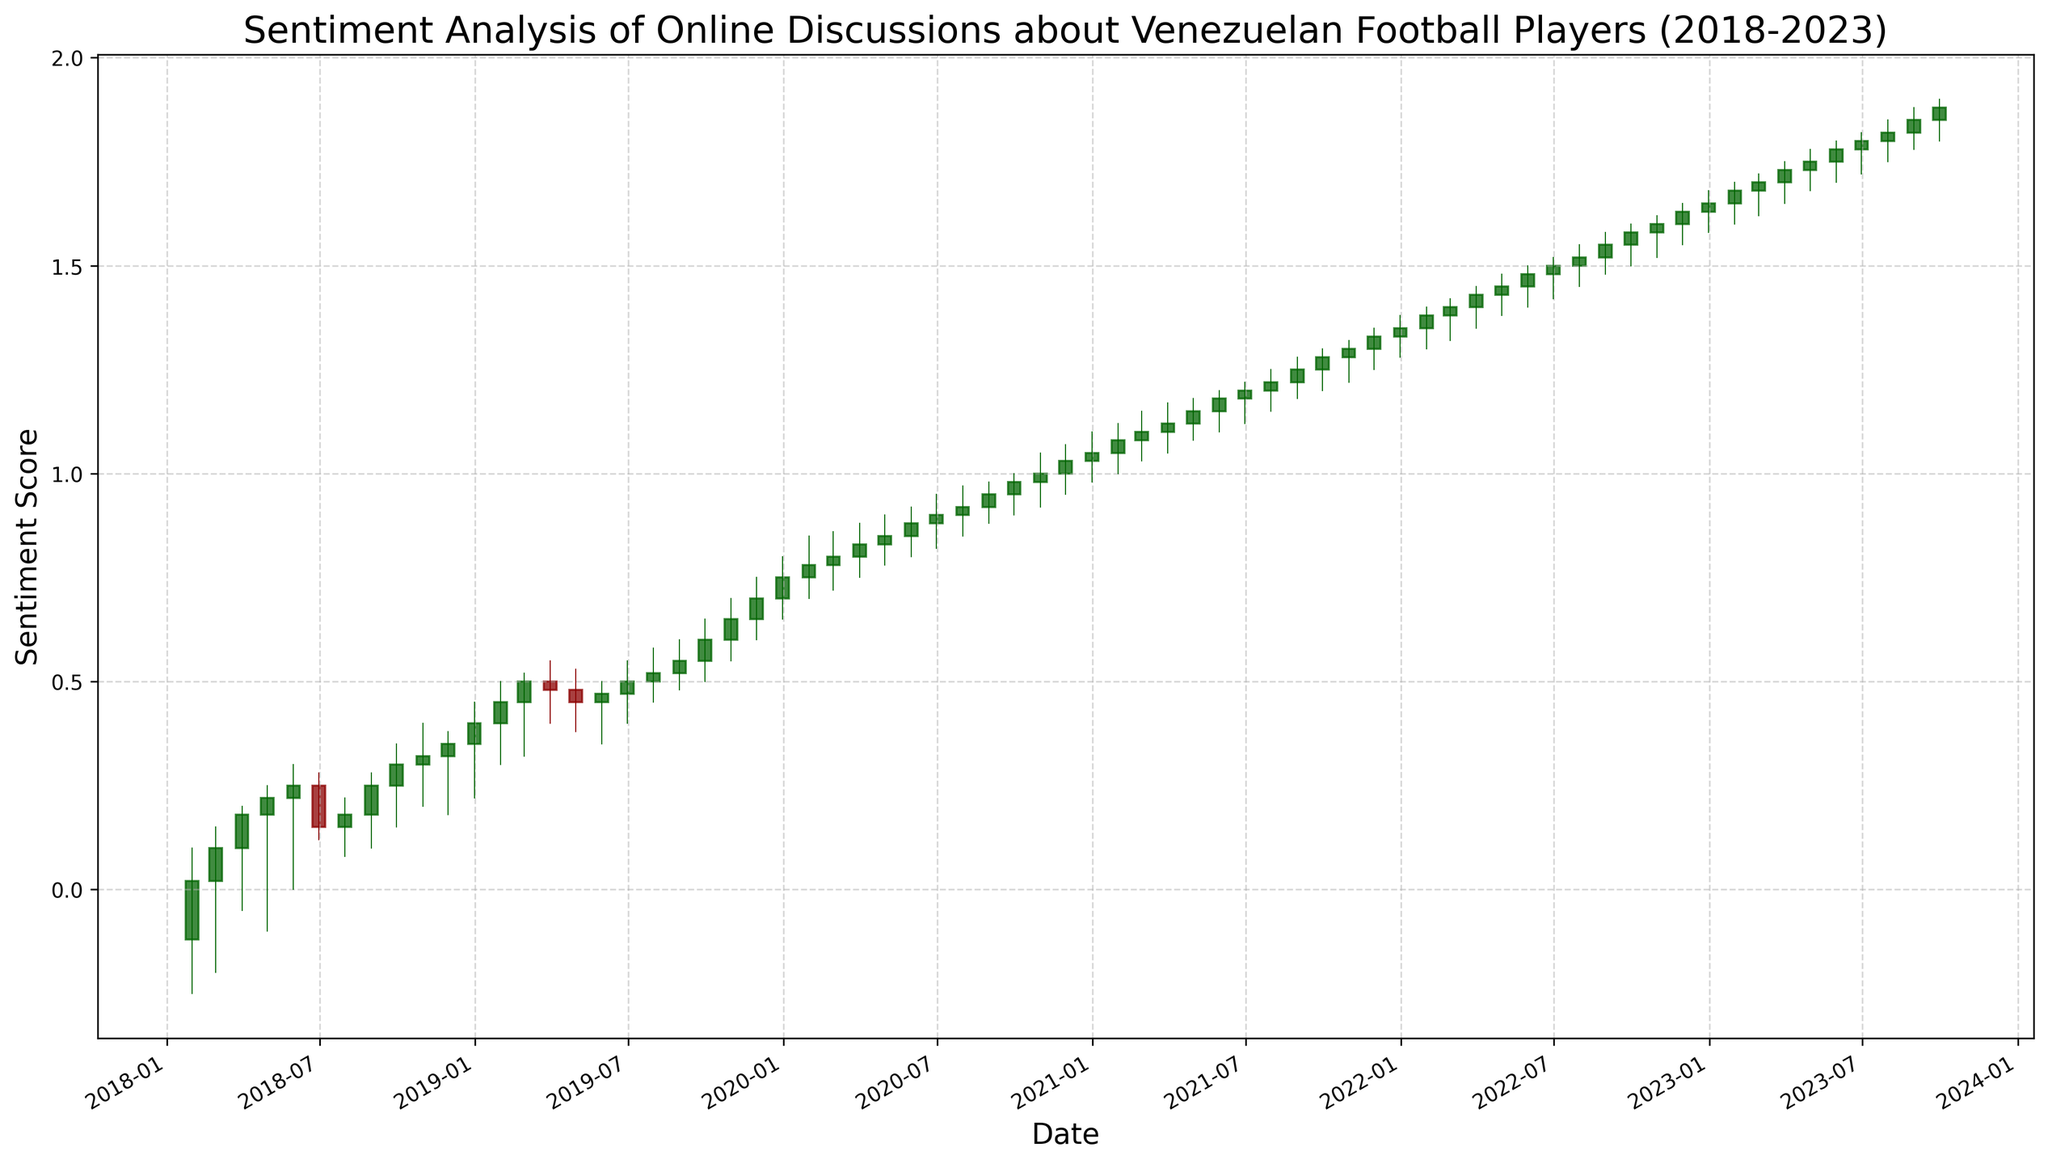What's the average sentiment score in the first quarter of 2018? To find the average sentiment score for the first quarter of 2018, sum the sentiment scores for January, February, and March, then divide by 3. In this case: (0.02 + 0.10 + 0.18) / 3 = 0.10
Answer: 0.10 Is the sentiment score trend generally increasing or decreasing from 2018 to 2023? Observe the overall direction of the candlestick bodies from left to right. The trend shows an overall increase as the sentiment scores mostly rise from 2018 to 2023.
Answer: Increasing In which month and year did the highest sentiment score occur? Identify the tallest green candlestick, indicating the highest closing value. This occurs in September 2023, where the close value is 1.88.
Answer: September 2023 How did the sentiment score change from December 2020 to January 2021? Compare the closing values of December 2020 and January 2021. The sentiment score increased from 1.05 in December 2020 to 1.08 in January 2021.
Answer: Increased by 0.03 Which month had the biggest positive change in sentiment score during 2018? Calculate the monthly differences and find the maximum. In 2018, the biggest positive change is from January (-0.12) to February (0.02), which is a change of 0.14.
Answer: February Was there any month in 2020 where the sentiment score decreased compared to the previous month? Check the closing values month-to-month in 2020. All months show an increase or the same value when compared to their previous month.
Answer: No What is the median sentiment score in 2019? List the closing values for each month in 2019 and find the middle value. The values are: 0.45, 0.50, 0.48, 0.45, 0.47, 0.50, 0.52, 0.55, 0.60, 0.65, 0.70, 0.75. The median is the average of the 6th and 7th values: (0.50 + 0.52) / 2 = 0.51
Answer: 0.51 Compare the sentiment score between June 2019 and June 2020. Which one is higher? Compare the closing values in June 2019 and June 2020. June 2019 has a score of 0.50, and June 2020 has a score of 0.90.
Answer: June 2020 is higher Which month in 2021 shows the least variability in sentiment score? Look for the smallest range (High - Low) in each month of 2021. The smallest range is observed in March 2021 (1.17 - 1.05 = 0.12).
Answer: March 2021 What was the sentiment score at the end of December 2019? Check the closing value of December 2019 on the candlestick chart. The closing value is 0.75.
Answer: 0.75 